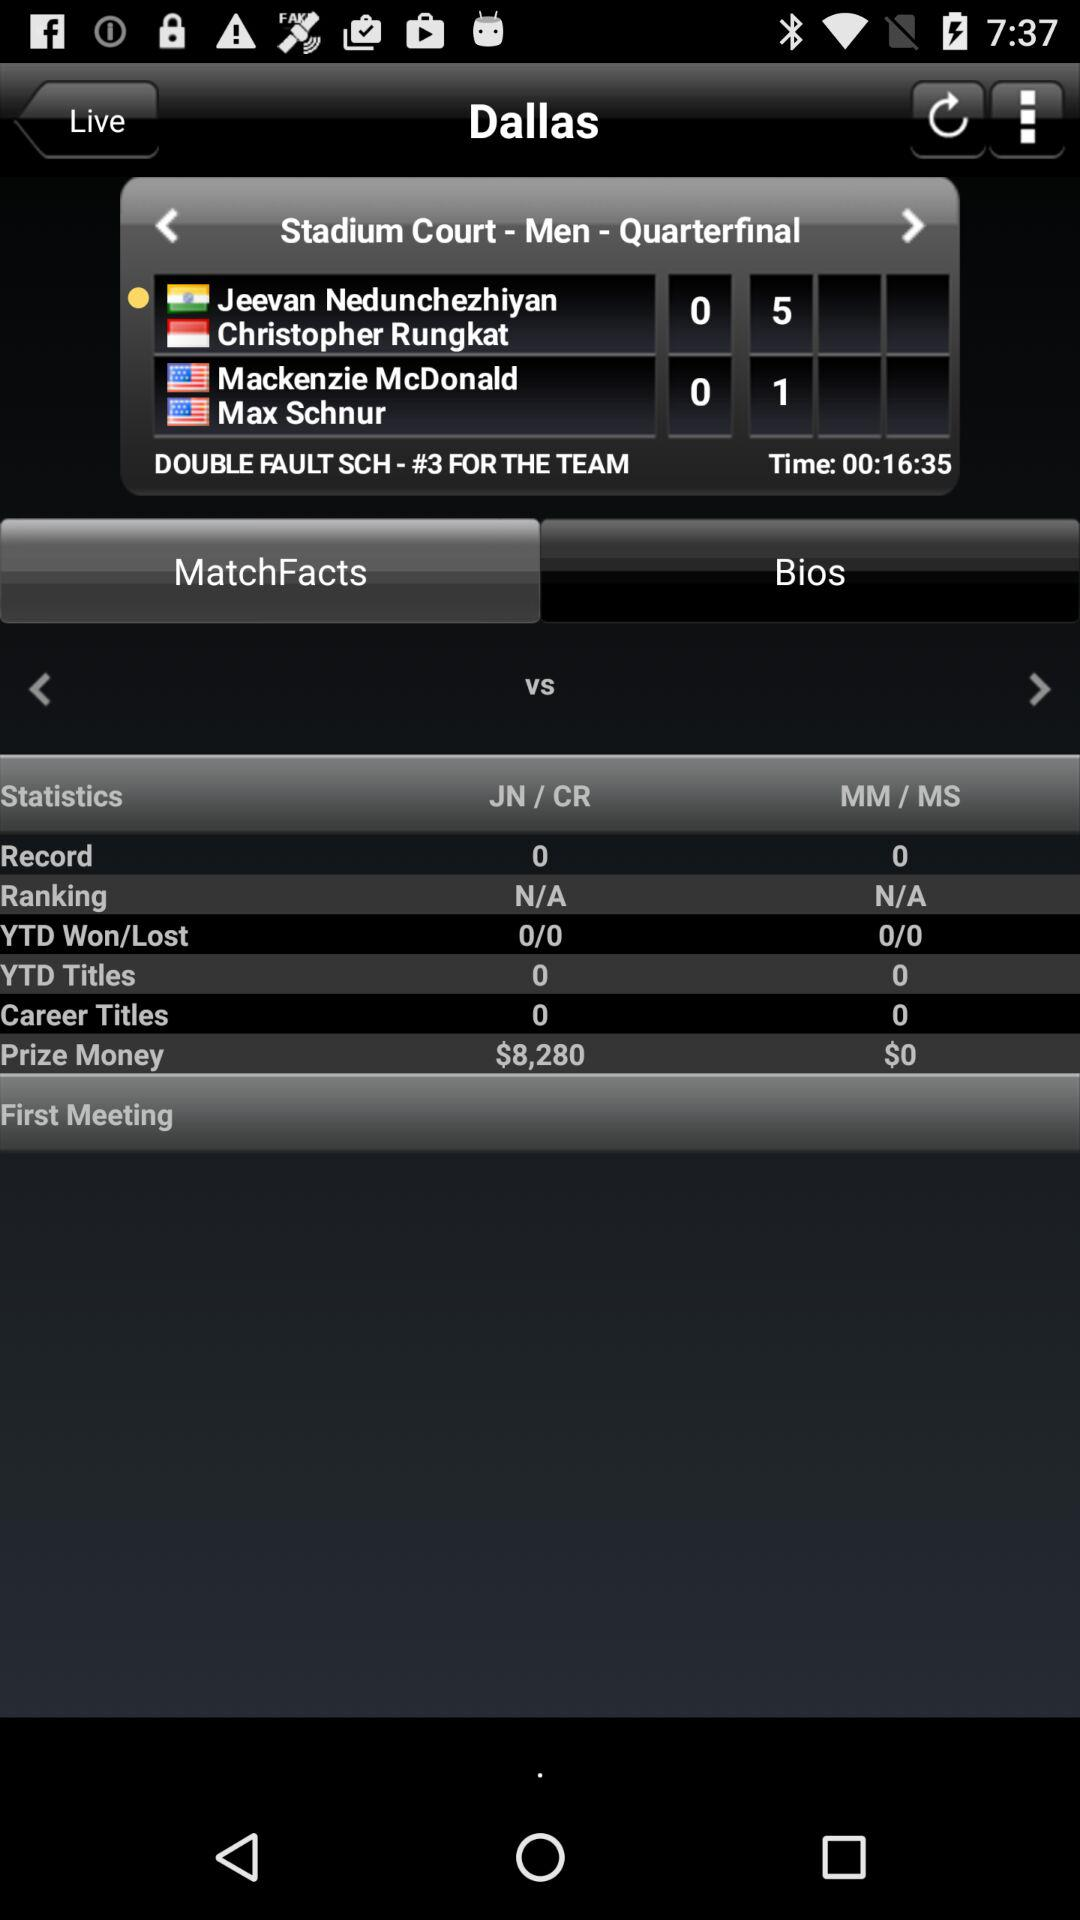What is the name of the player from India? The name of the player from India is Jeevan Nedunchezhiyan. 